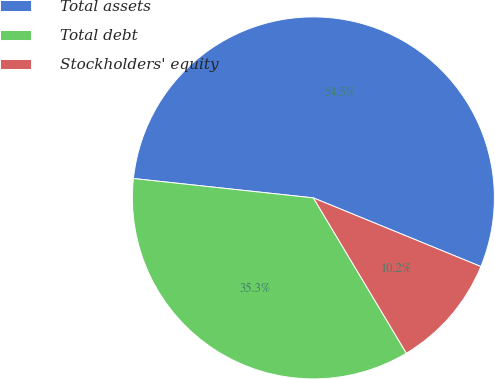Convert chart to OTSL. <chart><loc_0><loc_0><loc_500><loc_500><pie_chart><fcel>Total assets<fcel>Total debt<fcel>Stockholders' equity<nl><fcel>54.48%<fcel>35.29%<fcel>10.22%<nl></chart> 